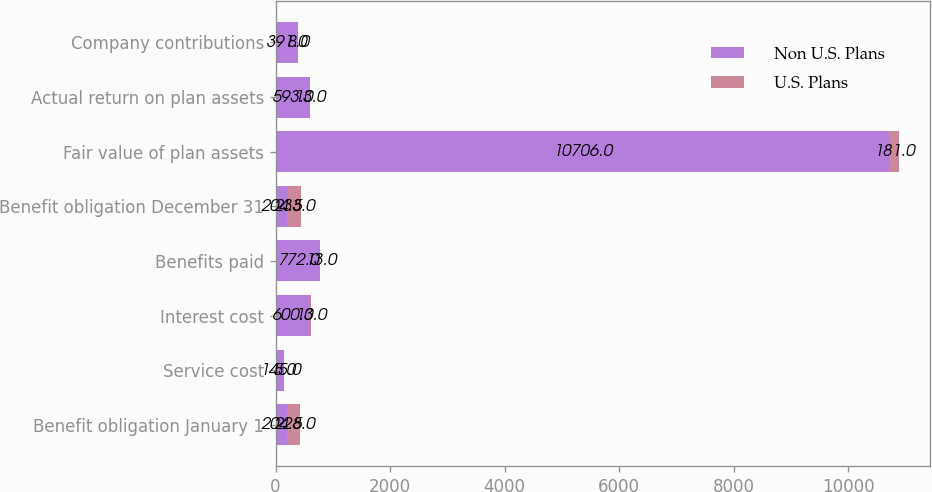<chart> <loc_0><loc_0><loc_500><loc_500><stacked_bar_chart><ecel><fcel>Benefit obligation January 1<fcel>Service cost<fcel>Interest cost<fcel>Benefits paid<fcel>Benefit obligation December 31<fcel>Fair value of plan assets<fcel>Actual return on plan assets<fcel>Company contributions<nl><fcel>Non U.S. Plans<fcel>204.5<fcel>145<fcel>600<fcel>772<fcel>204.5<fcel>10706<fcel>593<fcel>391<nl><fcel>U.S. Plans<fcel>228<fcel>5<fcel>13<fcel>13<fcel>233<fcel>181<fcel>13<fcel>8<nl></chart> 